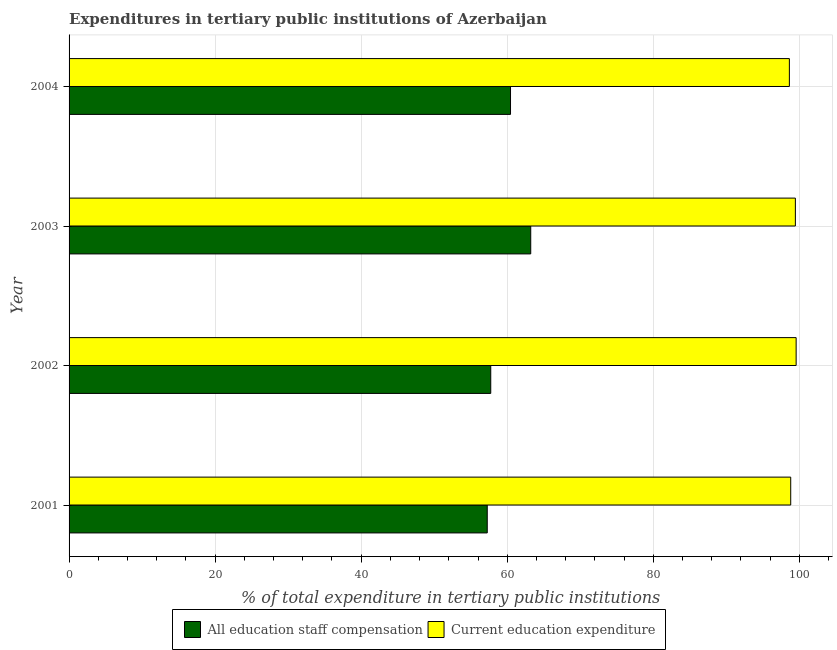How many different coloured bars are there?
Provide a succinct answer. 2. How many groups of bars are there?
Keep it short and to the point. 4. Are the number of bars on each tick of the Y-axis equal?
Offer a terse response. Yes. What is the label of the 4th group of bars from the top?
Your response must be concise. 2001. In how many cases, is the number of bars for a given year not equal to the number of legend labels?
Offer a very short reply. 0. What is the expenditure in staff compensation in 2004?
Make the answer very short. 60.45. Across all years, what is the maximum expenditure in education?
Provide a succinct answer. 99.56. Across all years, what is the minimum expenditure in education?
Your answer should be compact. 98.64. What is the total expenditure in staff compensation in the graph?
Give a very brief answer. 238.68. What is the difference between the expenditure in education in 2002 and that in 2004?
Offer a terse response. 0.93. What is the difference between the expenditure in education in 2004 and the expenditure in staff compensation in 2003?
Make the answer very short. 35.42. What is the average expenditure in staff compensation per year?
Keep it short and to the point. 59.67. In the year 2003, what is the difference between the expenditure in education and expenditure in staff compensation?
Your answer should be compact. 36.24. What is the ratio of the expenditure in education in 2001 to that in 2004?
Your response must be concise. 1. What is the difference between the highest and the second highest expenditure in education?
Ensure brevity in your answer.  0.1. What is the difference between the highest and the lowest expenditure in staff compensation?
Give a very brief answer. 5.95. In how many years, is the expenditure in staff compensation greater than the average expenditure in staff compensation taken over all years?
Give a very brief answer. 2. What does the 2nd bar from the top in 2002 represents?
Provide a short and direct response. All education staff compensation. What does the 2nd bar from the bottom in 2002 represents?
Give a very brief answer. Current education expenditure. How many bars are there?
Provide a short and direct response. 8. What is the difference between two consecutive major ticks on the X-axis?
Make the answer very short. 20. Are the values on the major ticks of X-axis written in scientific E-notation?
Ensure brevity in your answer.  No. Does the graph contain grids?
Make the answer very short. Yes. How many legend labels are there?
Your answer should be very brief. 2. What is the title of the graph?
Ensure brevity in your answer.  Expenditures in tertiary public institutions of Azerbaijan. What is the label or title of the X-axis?
Provide a succinct answer. % of total expenditure in tertiary public institutions. What is the % of total expenditure in tertiary public institutions of All education staff compensation in 2001?
Provide a short and direct response. 57.26. What is the % of total expenditure in tertiary public institutions of Current education expenditure in 2001?
Your answer should be very brief. 98.82. What is the % of total expenditure in tertiary public institutions of All education staff compensation in 2002?
Ensure brevity in your answer.  57.74. What is the % of total expenditure in tertiary public institutions in Current education expenditure in 2002?
Offer a terse response. 99.56. What is the % of total expenditure in tertiary public institutions in All education staff compensation in 2003?
Offer a very short reply. 63.22. What is the % of total expenditure in tertiary public institutions in Current education expenditure in 2003?
Your response must be concise. 99.46. What is the % of total expenditure in tertiary public institutions of All education staff compensation in 2004?
Make the answer very short. 60.45. What is the % of total expenditure in tertiary public institutions in Current education expenditure in 2004?
Make the answer very short. 98.64. Across all years, what is the maximum % of total expenditure in tertiary public institutions of All education staff compensation?
Your answer should be very brief. 63.22. Across all years, what is the maximum % of total expenditure in tertiary public institutions of Current education expenditure?
Keep it short and to the point. 99.56. Across all years, what is the minimum % of total expenditure in tertiary public institutions in All education staff compensation?
Offer a very short reply. 57.26. Across all years, what is the minimum % of total expenditure in tertiary public institutions of Current education expenditure?
Make the answer very short. 98.64. What is the total % of total expenditure in tertiary public institutions in All education staff compensation in the graph?
Make the answer very short. 238.68. What is the total % of total expenditure in tertiary public institutions of Current education expenditure in the graph?
Keep it short and to the point. 396.48. What is the difference between the % of total expenditure in tertiary public institutions in All education staff compensation in 2001 and that in 2002?
Ensure brevity in your answer.  -0.48. What is the difference between the % of total expenditure in tertiary public institutions of Current education expenditure in 2001 and that in 2002?
Offer a very short reply. -0.74. What is the difference between the % of total expenditure in tertiary public institutions of All education staff compensation in 2001 and that in 2003?
Provide a short and direct response. -5.95. What is the difference between the % of total expenditure in tertiary public institutions in Current education expenditure in 2001 and that in 2003?
Make the answer very short. -0.64. What is the difference between the % of total expenditure in tertiary public institutions of All education staff compensation in 2001 and that in 2004?
Your answer should be compact. -3.19. What is the difference between the % of total expenditure in tertiary public institutions of Current education expenditure in 2001 and that in 2004?
Offer a very short reply. 0.18. What is the difference between the % of total expenditure in tertiary public institutions of All education staff compensation in 2002 and that in 2003?
Provide a short and direct response. -5.47. What is the difference between the % of total expenditure in tertiary public institutions of Current education expenditure in 2002 and that in 2003?
Make the answer very short. 0.1. What is the difference between the % of total expenditure in tertiary public institutions of All education staff compensation in 2002 and that in 2004?
Your response must be concise. -2.71. What is the difference between the % of total expenditure in tertiary public institutions in Current education expenditure in 2002 and that in 2004?
Your answer should be very brief. 0.93. What is the difference between the % of total expenditure in tertiary public institutions of All education staff compensation in 2003 and that in 2004?
Provide a succinct answer. 2.77. What is the difference between the % of total expenditure in tertiary public institutions in Current education expenditure in 2003 and that in 2004?
Make the answer very short. 0.82. What is the difference between the % of total expenditure in tertiary public institutions in All education staff compensation in 2001 and the % of total expenditure in tertiary public institutions in Current education expenditure in 2002?
Your response must be concise. -42.3. What is the difference between the % of total expenditure in tertiary public institutions of All education staff compensation in 2001 and the % of total expenditure in tertiary public institutions of Current education expenditure in 2003?
Offer a terse response. -42.2. What is the difference between the % of total expenditure in tertiary public institutions in All education staff compensation in 2001 and the % of total expenditure in tertiary public institutions in Current education expenditure in 2004?
Offer a terse response. -41.37. What is the difference between the % of total expenditure in tertiary public institutions of All education staff compensation in 2002 and the % of total expenditure in tertiary public institutions of Current education expenditure in 2003?
Keep it short and to the point. -41.71. What is the difference between the % of total expenditure in tertiary public institutions of All education staff compensation in 2002 and the % of total expenditure in tertiary public institutions of Current education expenditure in 2004?
Your answer should be very brief. -40.89. What is the difference between the % of total expenditure in tertiary public institutions in All education staff compensation in 2003 and the % of total expenditure in tertiary public institutions in Current education expenditure in 2004?
Your answer should be very brief. -35.42. What is the average % of total expenditure in tertiary public institutions of All education staff compensation per year?
Give a very brief answer. 59.67. What is the average % of total expenditure in tertiary public institutions in Current education expenditure per year?
Your answer should be compact. 99.12. In the year 2001, what is the difference between the % of total expenditure in tertiary public institutions in All education staff compensation and % of total expenditure in tertiary public institutions in Current education expenditure?
Offer a terse response. -41.56. In the year 2002, what is the difference between the % of total expenditure in tertiary public institutions of All education staff compensation and % of total expenditure in tertiary public institutions of Current education expenditure?
Provide a short and direct response. -41.82. In the year 2003, what is the difference between the % of total expenditure in tertiary public institutions in All education staff compensation and % of total expenditure in tertiary public institutions in Current education expenditure?
Offer a very short reply. -36.24. In the year 2004, what is the difference between the % of total expenditure in tertiary public institutions in All education staff compensation and % of total expenditure in tertiary public institutions in Current education expenditure?
Provide a short and direct response. -38.19. What is the ratio of the % of total expenditure in tertiary public institutions of All education staff compensation in 2001 to that in 2002?
Ensure brevity in your answer.  0.99. What is the ratio of the % of total expenditure in tertiary public institutions of Current education expenditure in 2001 to that in 2002?
Your answer should be compact. 0.99. What is the ratio of the % of total expenditure in tertiary public institutions in All education staff compensation in 2001 to that in 2003?
Make the answer very short. 0.91. What is the ratio of the % of total expenditure in tertiary public institutions in All education staff compensation in 2001 to that in 2004?
Ensure brevity in your answer.  0.95. What is the ratio of the % of total expenditure in tertiary public institutions in All education staff compensation in 2002 to that in 2003?
Keep it short and to the point. 0.91. What is the ratio of the % of total expenditure in tertiary public institutions in All education staff compensation in 2002 to that in 2004?
Your answer should be very brief. 0.96. What is the ratio of the % of total expenditure in tertiary public institutions of Current education expenditure in 2002 to that in 2004?
Make the answer very short. 1.01. What is the ratio of the % of total expenditure in tertiary public institutions of All education staff compensation in 2003 to that in 2004?
Give a very brief answer. 1.05. What is the ratio of the % of total expenditure in tertiary public institutions in Current education expenditure in 2003 to that in 2004?
Make the answer very short. 1.01. What is the difference between the highest and the second highest % of total expenditure in tertiary public institutions of All education staff compensation?
Offer a terse response. 2.77. What is the difference between the highest and the second highest % of total expenditure in tertiary public institutions in Current education expenditure?
Your answer should be very brief. 0.1. What is the difference between the highest and the lowest % of total expenditure in tertiary public institutions in All education staff compensation?
Ensure brevity in your answer.  5.95. What is the difference between the highest and the lowest % of total expenditure in tertiary public institutions of Current education expenditure?
Provide a succinct answer. 0.93. 